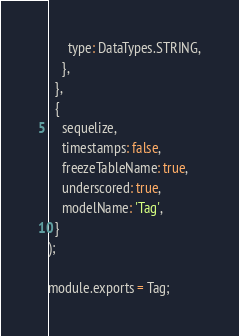Convert code to text. <code><loc_0><loc_0><loc_500><loc_500><_JavaScript_>      type: DataTypes.STRING,
    },
  },
  {
    sequelize,
    timestamps: false,
    freezeTableName: true,
    underscored: true,
    modelName: 'Tag',
  }
);

module.exports = Tag;
</code> 